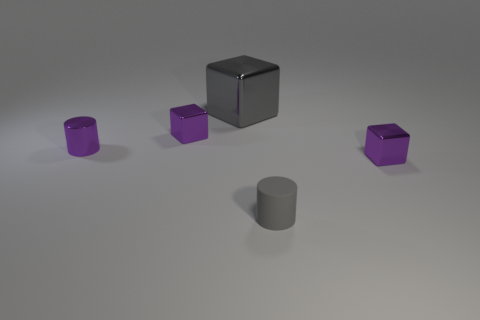Add 1 tiny yellow blocks. How many objects exist? 6 Subtract all cylinders. How many objects are left? 3 Add 2 small gray rubber cylinders. How many small gray rubber cylinders are left? 3 Add 4 gray objects. How many gray objects exist? 6 Subtract 0 brown cubes. How many objects are left? 5 Subtract all shiny things. Subtract all brown shiny balls. How many objects are left? 1 